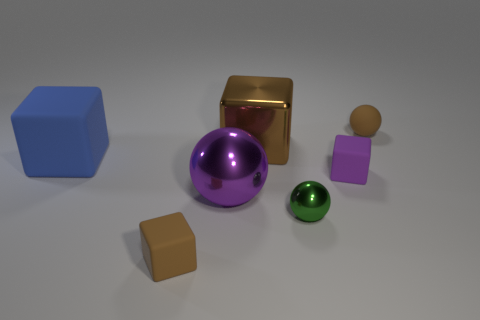Add 3 big yellow matte things. How many objects exist? 10 Subtract all balls. How many objects are left? 4 Subtract all tiny brown spheres. Subtract all brown cubes. How many objects are left? 4 Add 3 tiny metal things. How many tiny metal things are left? 4 Add 1 small brown things. How many small brown things exist? 3 Subtract 0 gray balls. How many objects are left? 7 